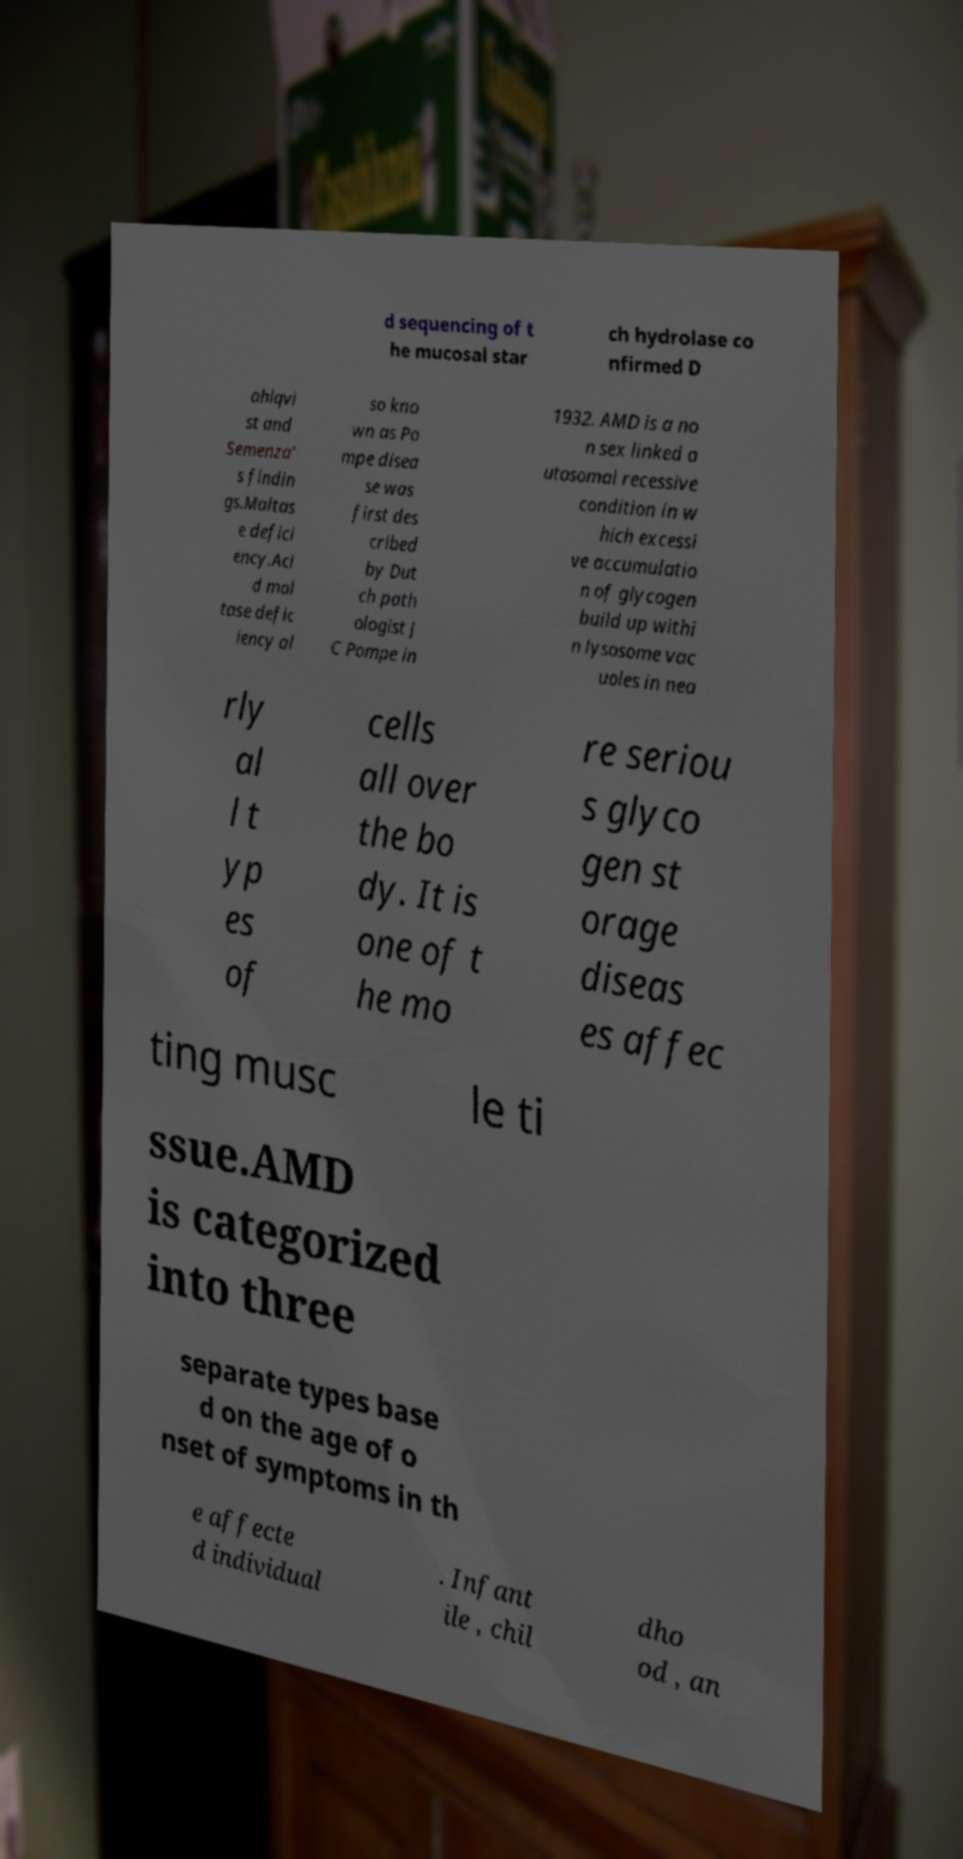Could you extract and type out the text from this image? d sequencing of t he mucosal star ch hydrolase co nfirmed D ahlqvi st and Semenza' s findin gs.Maltas e defici ency.Aci d mal tase defic iency al so kno wn as Po mpe disea se was first des cribed by Dut ch path ologist J C Pompe in 1932. AMD is a no n sex linked a utosomal recessive condition in w hich excessi ve accumulatio n of glycogen build up withi n lysosome vac uoles in nea rly al l t yp es of cells all over the bo dy. It is one of t he mo re seriou s glyco gen st orage diseas es affec ting musc le ti ssue.AMD is categorized into three separate types base d on the age of o nset of symptoms in th e affecte d individual . Infant ile , chil dho od , an 